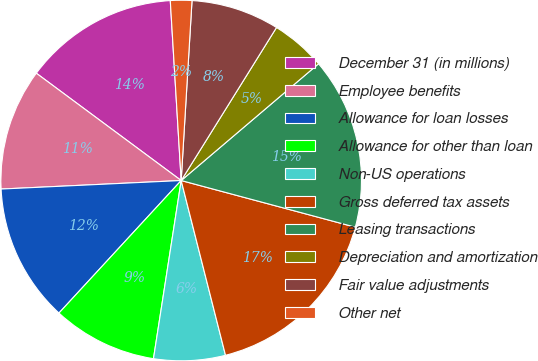<chart> <loc_0><loc_0><loc_500><loc_500><pie_chart><fcel>December 31 (in millions)<fcel>Employee benefits<fcel>Allowance for loan losses<fcel>Allowance for other than loan<fcel>Non-US operations<fcel>Gross deferred tax assets<fcel>Leasing transactions<fcel>Depreciation and amortization<fcel>Fair value adjustments<fcel>Other net<nl><fcel>13.89%<fcel>10.9%<fcel>12.39%<fcel>9.4%<fcel>6.41%<fcel>16.88%<fcel>15.38%<fcel>4.92%<fcel>7.91%<fcel>1.92%<nl></chart> 